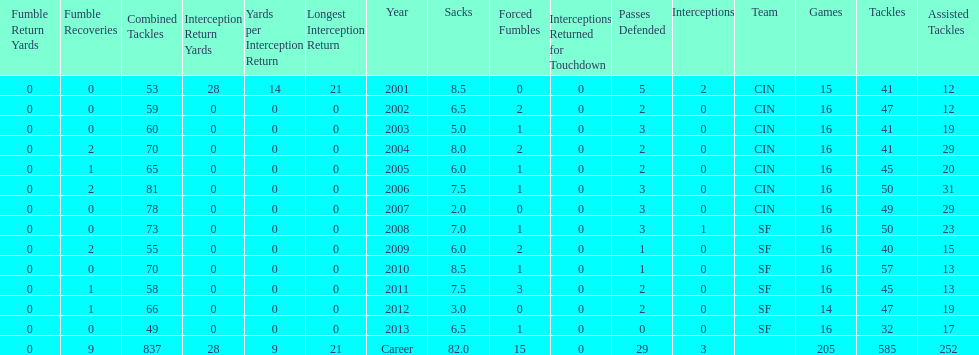How many sacks did this player have in his first five seasons? 34. 